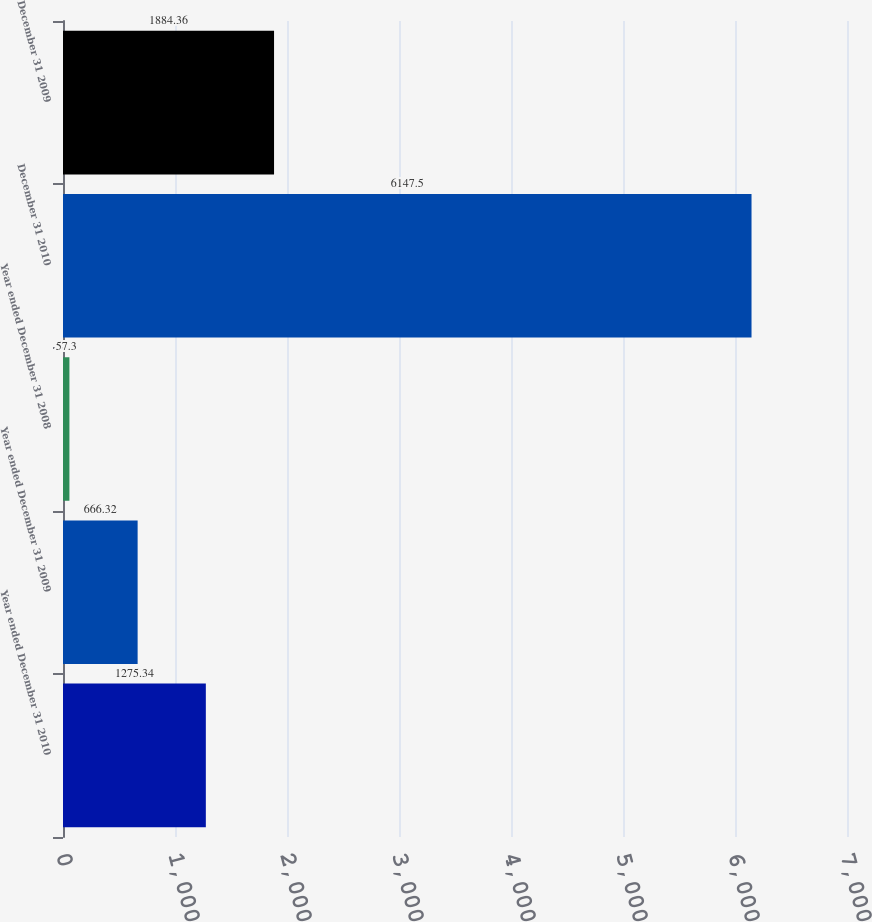<chart> <loc_0><loc_0><loc_500><loc_500><bar_chart><fcel>Year ended December 31 2010<fcel>Year ended December 31 2009<fcel>Year ended December 31 2008<fcel>December 31 2010<fcel>December 31 2009<nl><fcel>1275.34<fcel>666.32<fcel>57.3<fcel>6147.5<fcel>1884.36<nl></chart> 